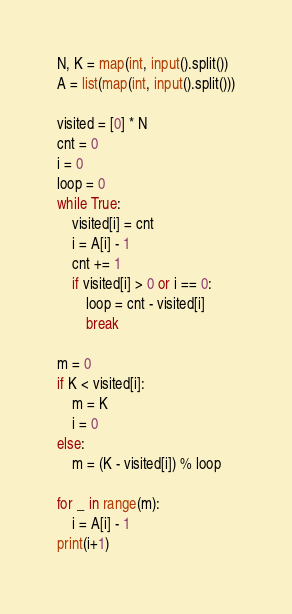Convert code to text. <code><loc_0><loc_0><loc_500><loc_500><_Python_>N, K = map(int, input().split())
A = list(map(int, input().split()))

visited = [0] * N
cnt = 0
i = 0
loop = 0
while True:
    visited[i] = cnt
    i = A[i] - 1
    cnt += 1
    if visited[i] > 0 or i == 0:
        loop = cnt - visited[i]
        break

m = 0
if K < visited[i]:
    m = K
    i = 0
else:
    m = (K - visited[i]) % loop

for _ in range(m):
    i = A[i] - 1
print(i+1)
</code> 